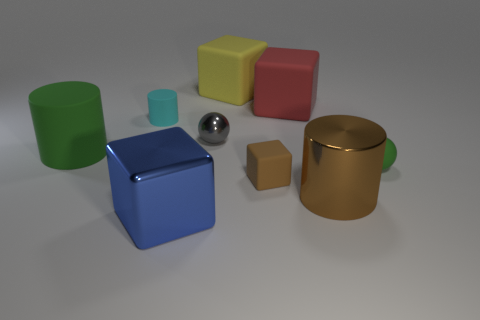Add 1 yellow blocks. How many objects exist? 10 Subtract all cylinders. How many objects are left? 6 Subtract all large matte objects. Subtract all green matte spheres. How many objects are left? 5 Add 4 tiny brown rubber cubes. How many tiny brown rubber cubes are left? 5 Add 5 small rubber blocks. How many small rubber blocks exist? 6 Subtract 0 gray cylinders. How many objects are left? 9 